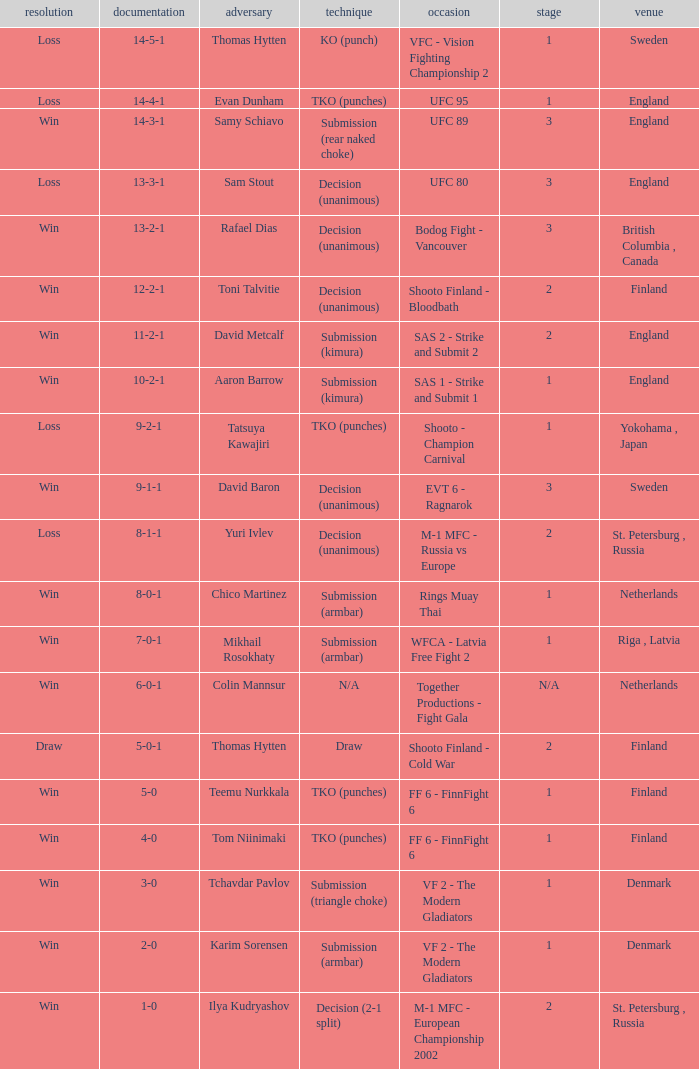What's the location when the record was 6-0-1? Netherlands. 